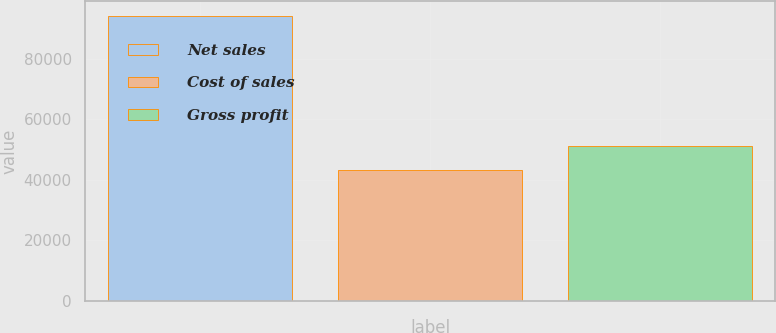Convert chart. <chart><loc_0><loc_0><loc_500><loc_500><bar_chart><fcel>Net sales<fcel>Cost of sales<fcel>Gross profit<nl><fcel>94241<fcel>43059<fcel>51183<nl></chart> 